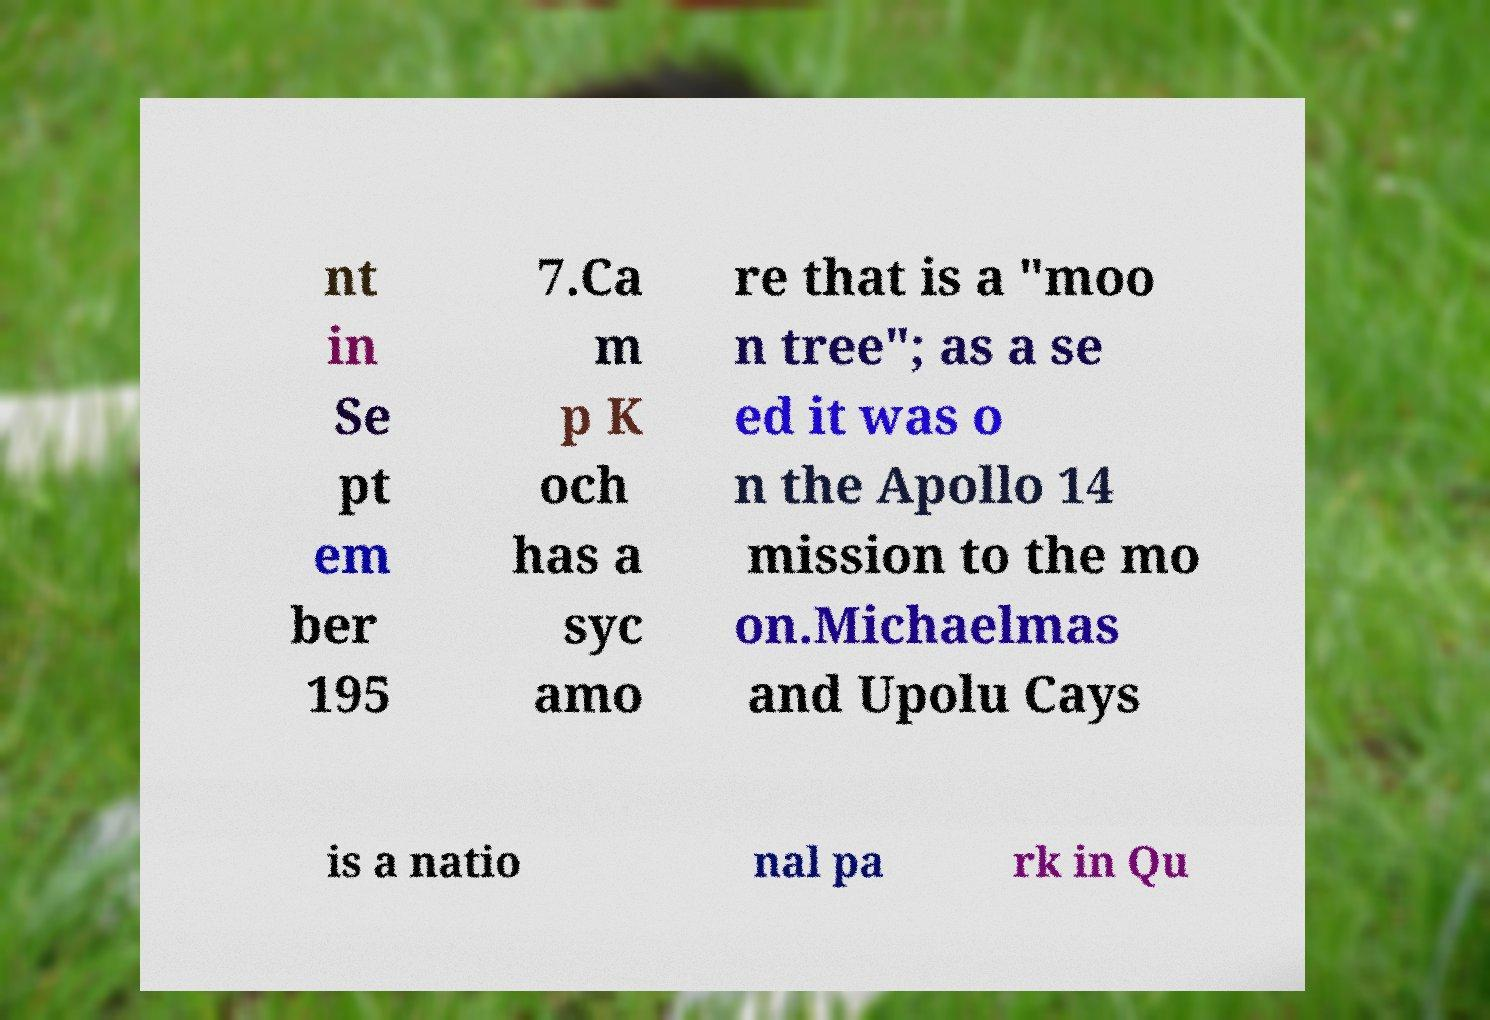Please read and relay the text visible in this image. What does it say? nt in Se pt em ber 195 7.Ca m p K och has a syc amo re that is a "moo n tree"; as a se ed it was o n the Apollo 14 mission to the mo on.Michaelmas and Upolu Cays is a natio nal pa rk in Qu 